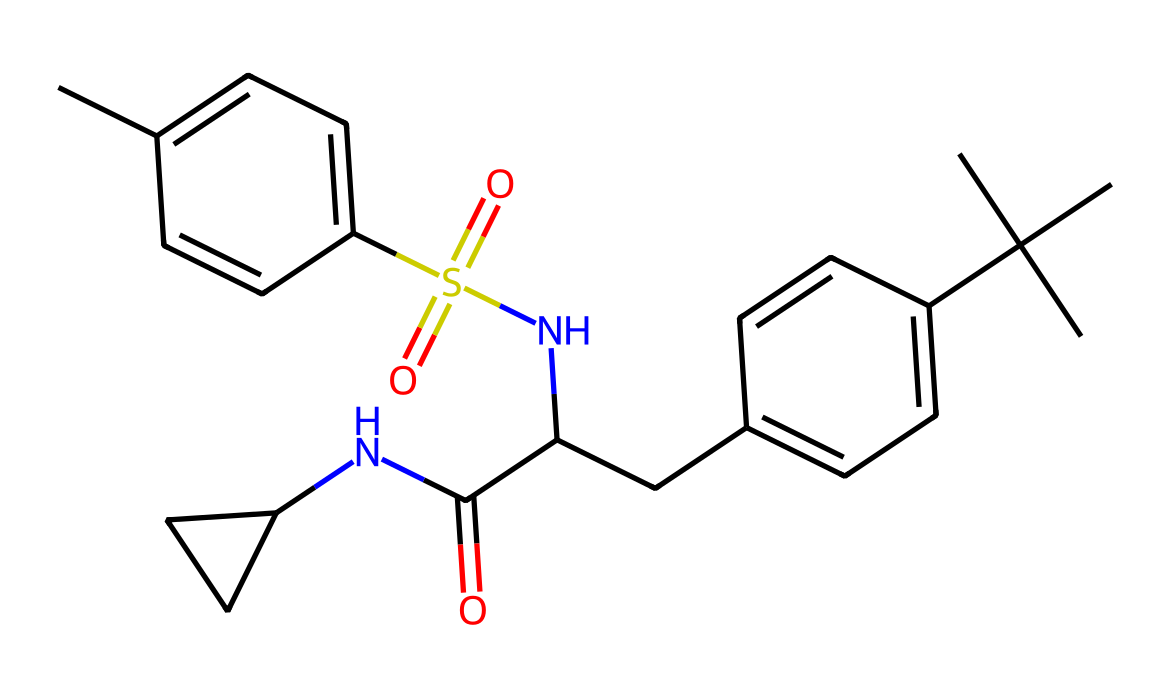What is the main functional group present in this chemical structure? By analyzing the structure, we can identify the presence of a sulfonamide group, which contains the sulfur atom double bonded to two oxygen atoms (sulfonyl) and bonded to a nitrogen atom (amide). This is a defining characteristic of sulfonamide compounds.
Answer: sulfonamide How many cycles are present in the structure? Upon examining the chemical structure, it is evident that there are two aromatic rings (each cycle is a phenolic structure) contributing to cyclic components. The nitrogen-containing cycle (e.g., the cyclic amine) also adds to the count. Therefore, there are three cycles.
Answer: three What type of bonding is primarily occurring in this molecule? The structure comprises mainly covalent bonds due to the sharing of electrons between atoms, particularly in the carbon backbone and functional groups, typical for organic compounds.
Answer: covalent bonds What is the highest oxidation state of carbon in this chemical? Reviewing the carbons in the structure, the carbon in the carboxyl group (C(=O)OH) exhibits a higher oxidation state, marked by its double bond to oxygen, indicating it is in a +4 state.
Answer: +4 Which molecular feature contributes to the sweetness of this compound? The presence of nitrogen in the amide functional groups and specific carbon configurations generally increases sweetness, especially in artificial sweeteners. This arrangement is integral to the molecule's sweet taste profile.
Answer: amide groups How many nitrogen atoms are present in the molecule? A count of the atoms in the structure reveals there are two nitrogen atoms embedded within the amide groups impacting the chemical's biological activity and taste.
Answer: two What is the overall charge of the molecule? Considering the bonding and functional groups present, there are no charges indicated in the structure, leading to a conclusion that the overall charge of the molecule is neutral.
Answer: neutral 